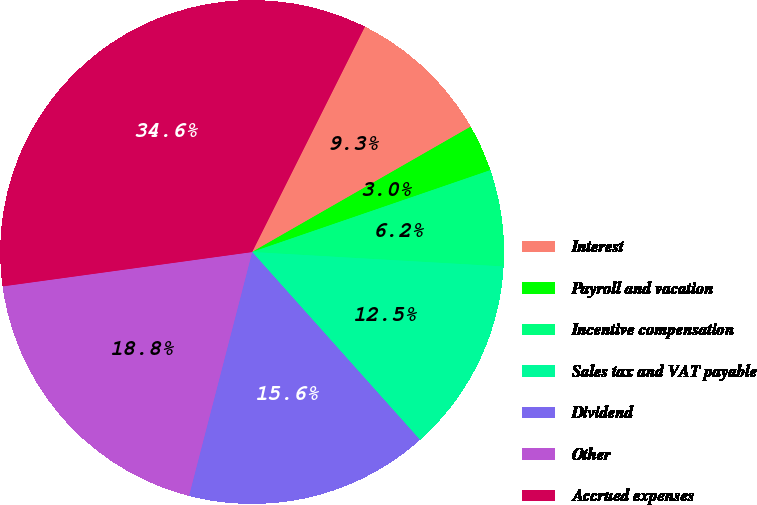Convert chart. <chart><loc_0><loc_0><loc_500><loc_500><pie_chart><fcel>Interest<fcel>Payroll and vacation<fcel>Incentive compensation<fcel>Sales tax and VAT payable<fcel>Dividend<fcel>Other<fcel>Accrued expenses<nl><fcel>9.33%<fcel>3.02%<fcel>6.18%<fcel>12.48%<fcel>15.64%<fcel>18.79%<fcel>34.56%<nl></chart> 